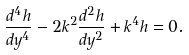Convert formula to latex. <formula><loc_0><loc_0><loc_500><loc_500>\frac { d ^ { 4 } h } { d y ^ { 4 } } - 2 k ^ { 2 } \frac { d ^ { 2 } h } { d y ^ { 2 } } + k ^ { 4 } h = 0 .</formula> 